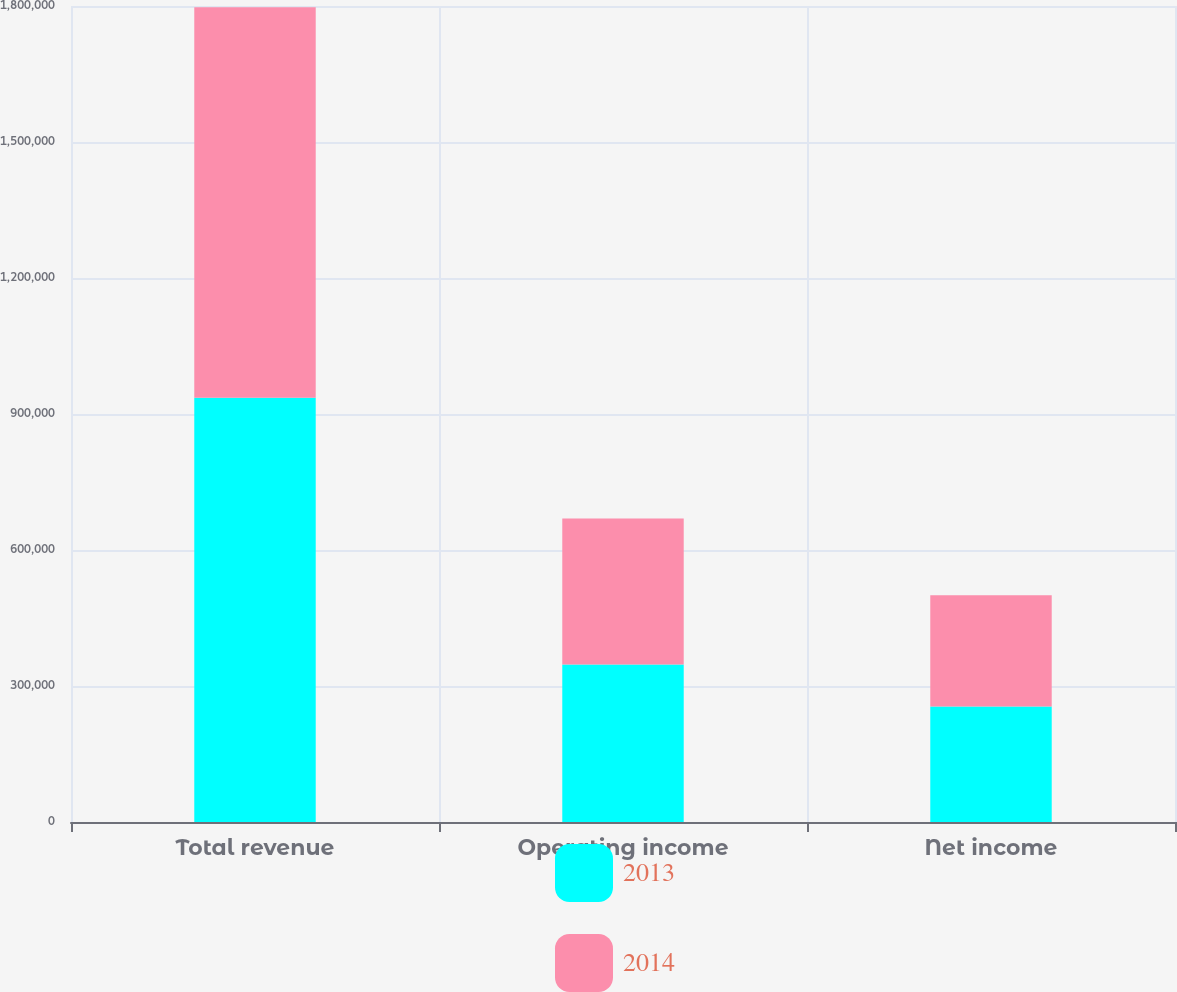Convert chart. <chart><loc_0><loc_0><loc_500><loc_500><stacked_bar_chart><ecel><fcel>Total revenue<fcel>Operating income<fcel>Net income<nl><fcel>2013<fcel>936021<fcel>347450<fcel>254690<nl><fcel>2014<fcel>861260<fcel>321863<fcel>245327<nl></chart> 